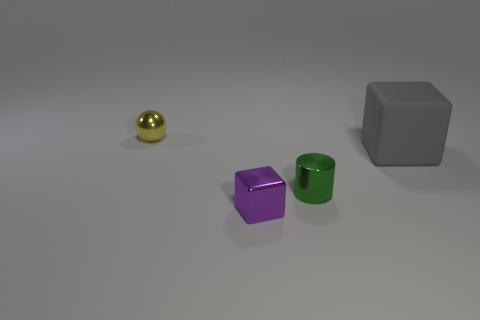Are there any other things that have the same size as the gray object?
Offer a terse response. No. Is there anything else that is the same color as the tiny cylinder?
Ensure brevity in your answer.  No. How big is the cube that is right of the purple metal thing?
Your answer should be compact. Large. There is a cube in front of the tiny shiny object on the right side of the object in front of the green metallic cylinder; how big is it?
Offer a terse response. Small. What color is the object that is behind the cube to the right of the green metal object?
Your answer should be very brief. Yellow. There is a small purple thing that is the same shape as the gray matte object; what is it made of?
Provide a short and direct response. Metal. Is there any other thing that has the same material as the gray thing?
Give a very brief answer. No. There is a small cylinder; are there any large gray objects behind it?
Provide a succinct answer. Yes. What number of blocks are there?
Your answer should be very brief. 2. There is a tiny object in front of the small green object; what number of tiny shiny things are right of it?
Provide a short and direct response. 1. 